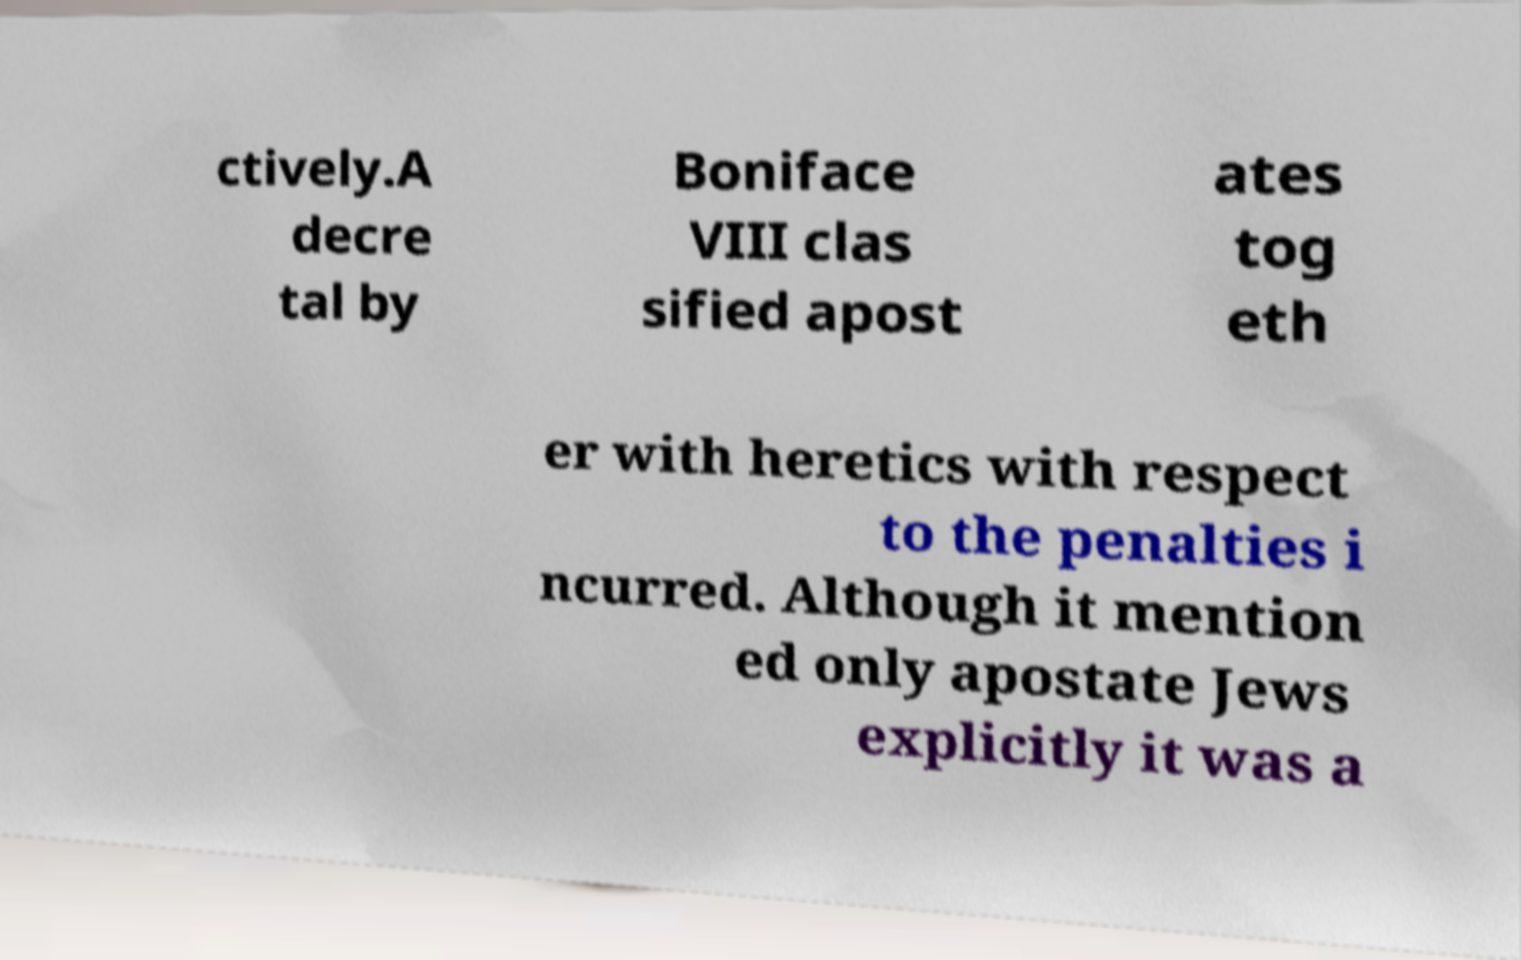Could you assist in decoding the text presented in this image and type it out clearly? ctively.A decre tal by Boniface VIII clas sified apost ates tog eth er with heretics with respect to the penalties i ncurred. Although it mention ed only apostate Jews explicitly it was a 